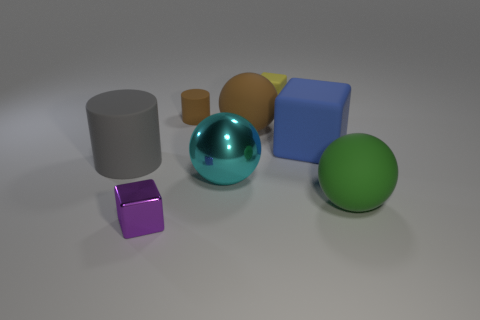What might be the purpose of depicting these objects together? The collection of objects might serve several purposes. It could be an artistic composition designed to explore shape, texture, and color contrast. Alternatively, it could be part of a visual study for educational purposes, helping viewers understand the characteristics of different materials and geometries. This grouping invites contemplation on the interplay of light, shadow, and the tactile qualities of surfaces. 